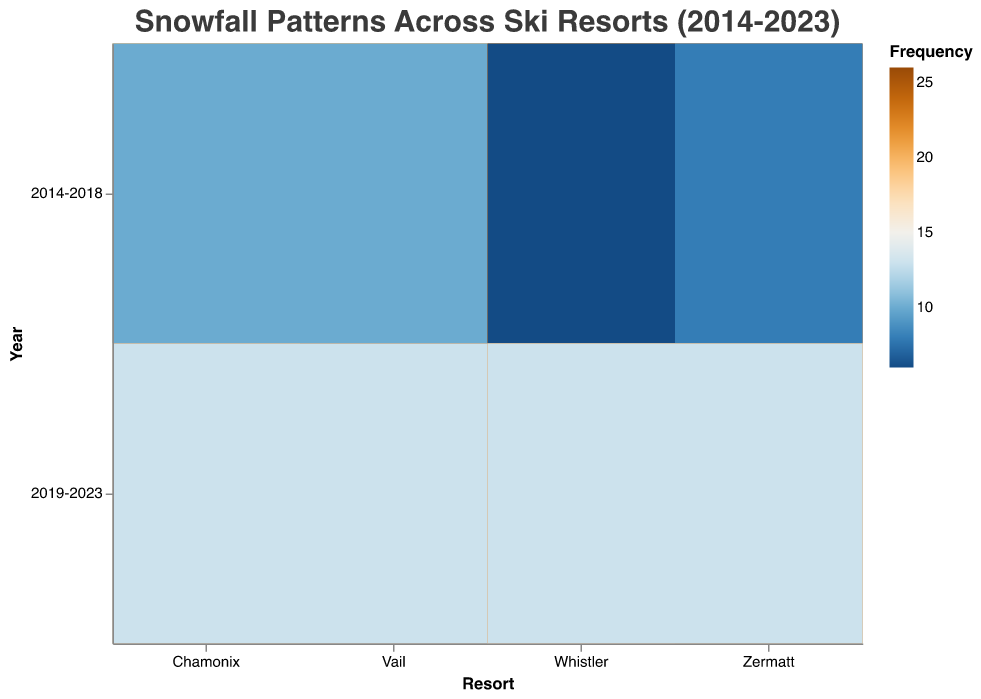What's the overall trend in "Above Average" snowfall from 2014-2018 to 2019-2023 across all resorts? To identify the trend, look at the "Above Average" rectangles for each resort in both time periods. For Vail, it decreases from 18 to 12; for Whistler, it decreases from 20 to 15; for Zermatt, it decreases from 16 to 14; and for Chamonix, it decreases from 19 to 13. Thus, the overall trend is a decrease.
Answer: Decrease Which resort had the highest frequency of "Below Average" snowfall in 2019-2023 and what was the value? Look at the 2019-2023 section for "Below Average" snowfall for each resort. Vail and Whistler both have a frequency of 13, Zermatt also has 13, and Chamonix has 13. All four have the same highest value.
Answer: Vail, Whistler, Zermatt, Chamonix; 13 Comparing "Average" snowfall, which resort showed the highest increase in frequency from 2014-2018 to 2019-2023? Calculate the change in frequency for the "Average" category from 2014-2018 to 2019-2023 for each resort. Vail increased from 22 to 25 (3), Whistler decreased from 24 to 22 (-2), Zermatt decreased from 26 to 23 (-3), and Chamonix increased from 21 to 24 (3).
Answer: Tie between Vail and Chamonix What is the common trend seen in "Below Average" snowfall across all resorts from 2014-2018 to 2019-2023? Observe the frequencies in "Below Average" snowfall for all resorts. For Vail, it increased from 10 to 13; for Whistler, it increased from 6 to 13; for Zermatt, it increased from 8 to 13; and for Chamonix, it increased from 10 to 13. The common trend is an increase.
Answer: Increase For Whistler, how does the "Above Average" snowfall frequency in 2014-2018 compare to 2019-2023? Look at Whistler's "Above Average" category in the two time periods. The frequency decreases from 20 to 15.
Answer: Decrease Which resort experienced the smallest change in "Above Average" snowfall frequency from 2014-2018 to 2019-2023? Compare the change in "Above Average" frequencies for each resort: Vail (18 to 12, -6), Whistler (20 to 15, -5), Zermatt (16 to 14, -2), and Chamonix (19 to 13, -6). Zermatt experienced the smallest change.
Answer: Zermatt How does the frequency of "Average" snowfall in Chamonix during 2014-2018 compare to Zermatt during the same period? Look at the frequencies in the "Average" snowfall category for Chamonix and Zermatt during 2014-2018. Chamonix has a frequency of 21, and Zermatt has 26.
Answer: Chamonix is lower Which category of snowfall saw the most frequent occurrences across all resorts for both time periods combined? Sum the frequencies of "Above Average," "Average," and "Below Average" for all resorts in both 2014-2018 and 2019-2023. "Above Average" has 18+12+20+15+16+14+19+13=127, "Average" has 22+25+24+22+26+23+21+24=187, "Below Average" has 10+13+6+13+8+13+10+13=86. "Average" has the highest frequency.
Answer: Average 